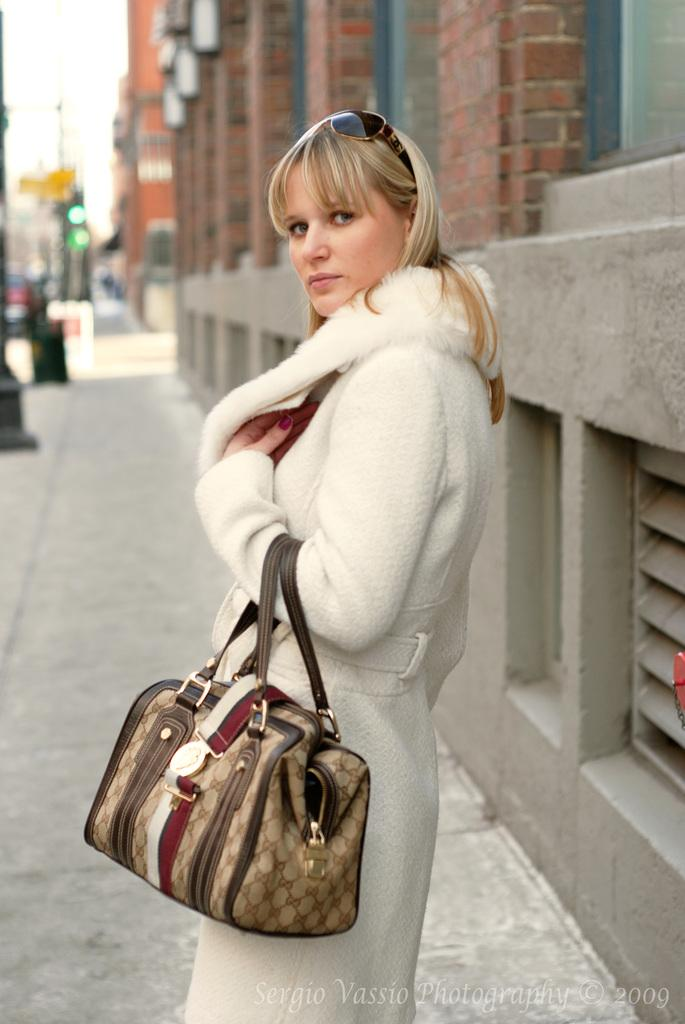Who is present in the image? There is a woman in the image. What is the woman holding? The woman is holding a handbag. What is the woman's posture in the image? The woman is standing. What can be seen in the background of the image? There are buildings, a signal light, and a pole in the background of the image. What type of apple is the creature holding in the image? There is no creature or apple present in the image. How many balloons are tied to the pole in the image? There are no balloons present in the image; only a pole and other background elements are visible. 